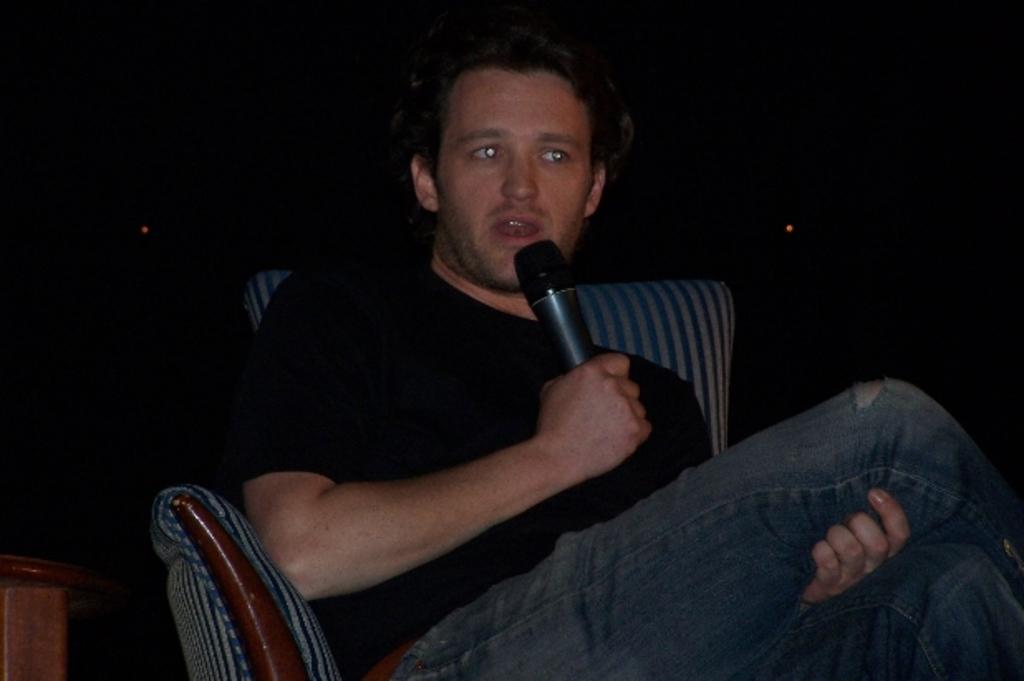What is the main subject of the image? The main subject of the image is a man. What is the man doing in the image? The man is sitting on a chair and holding a microphone. What is the man wearing in the image? The man is wearing a black T-shirt and blue jeans. What can be observed about the background of the image? The background of the image is dark in color. How many icicles are hanging from the man's shirt in the image? There are no icicles present in the image. What type of rod is the man using to hold the microphone in the image? The man is not using a rod to hold the microphone; he is simply holding it in his hand. 